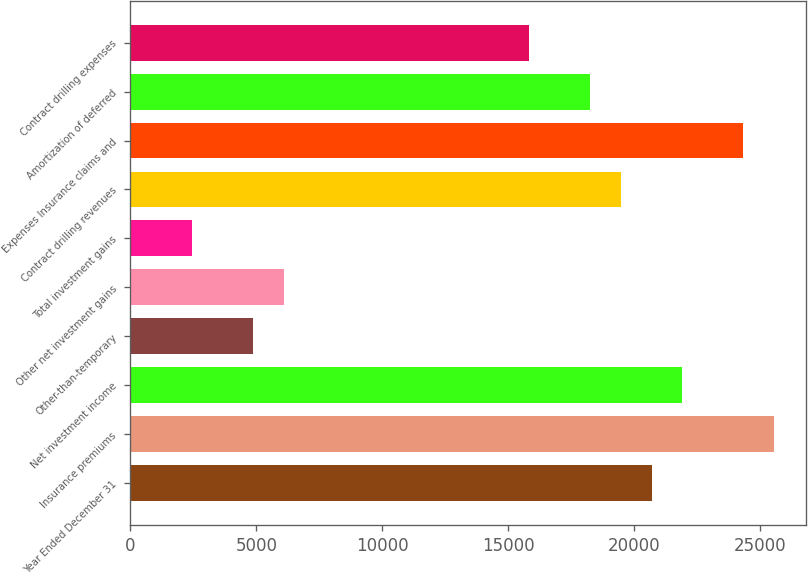Convert chart to OTSL. <chart><loc_0><loc_0><loc_500><loc_500><bar_chart><fcel>Year Ended December 31<fcel>Insurance premiums<fcel>Net investment income<fcel>Other-than-temporary<fcel>Other net investment gains<fcel>Total investment gains<fcel>Contract drilling revenues<fcel>Expenses Insurance claims and<fcel>Amortization of deferred<fcel>Contract drilling expenses<nl><fcel>20687.1<fcel>25554.6<fcel>21904<fcel>4867.74<fcel>6084.61<fcel>2433.99<fcel>19470.2<fcel>24337.7<fcel>18253.3<fcel>15819.6<nl></chart> 